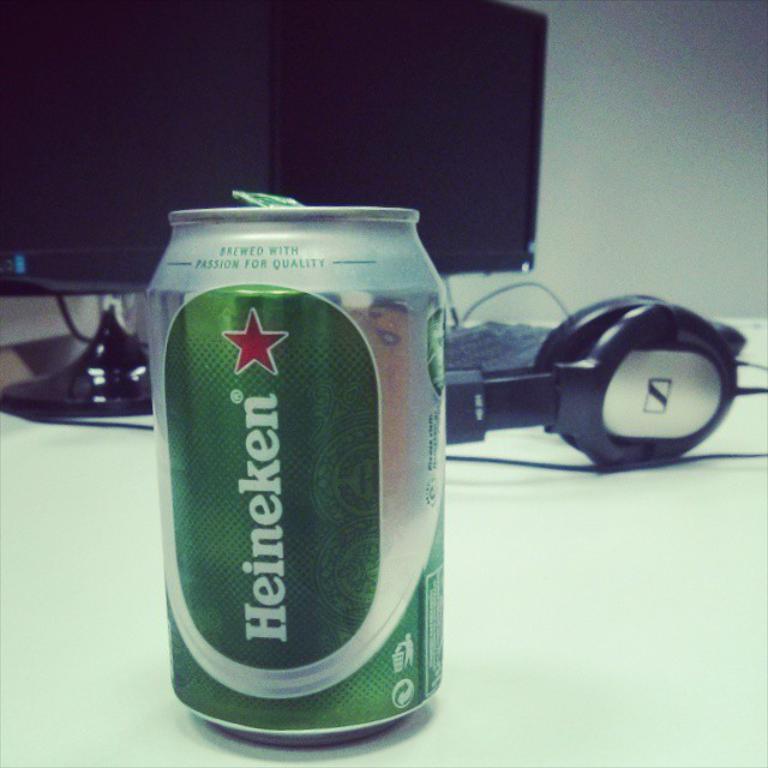What is the name of this beer?
Keep it short and to the point. Heineken. What brand of beer is this?
Provide a short and direct response. Heineken. 